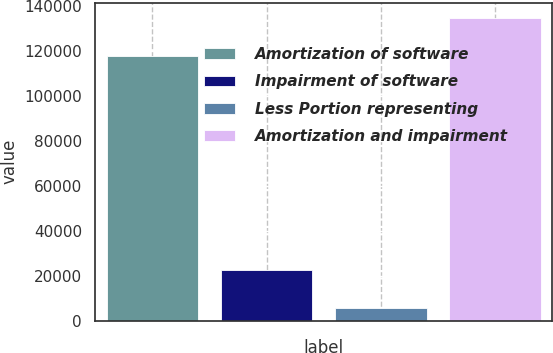<chart> <loc_0><loc_0><loc_500><loc_500><bar_chart><fcel>Amortization of software<fcel>Impairment of software<fcel>Less Portion representing<fcel>Amortization and impairment<nl><fcel>117506<fcel>22671<fcel>5705<fcel>134472<nl></chart> 